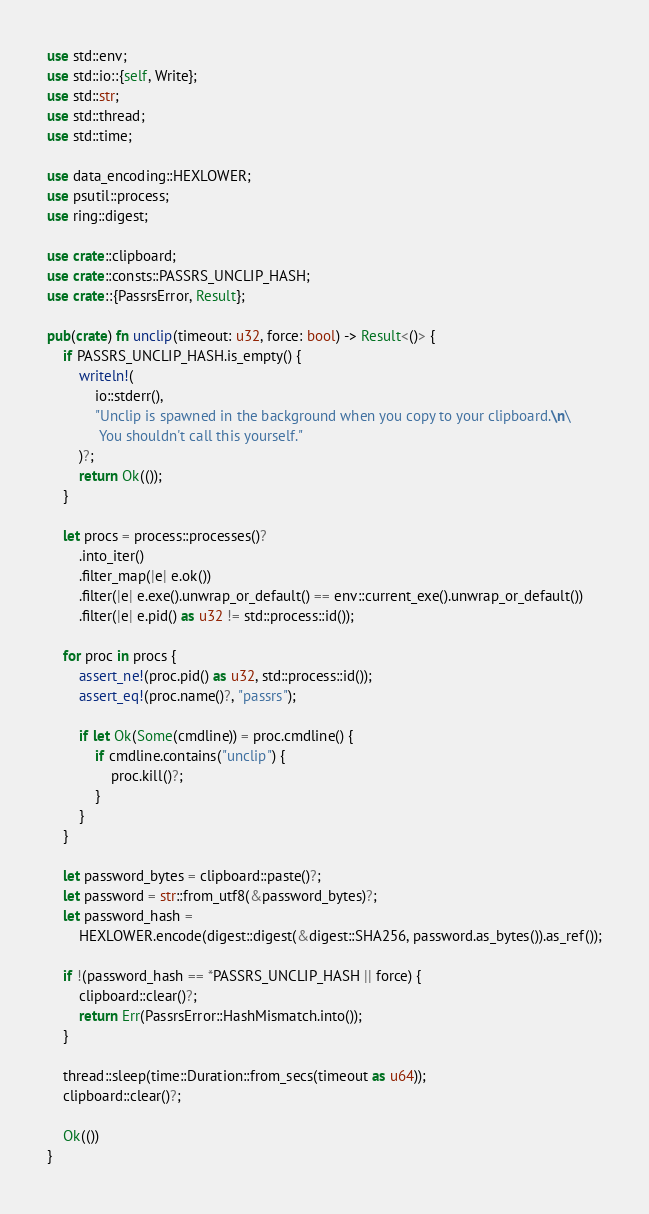Convert code to text. <code><loc_0><loc_0><loc_500><loc_500><_Rust_>use std::env;
use std::io::{self, Write};
use std::str;
use std::thread;
use std::time;

use data_encoding::HEXLOWER;
use psutil::process;
use ring::digest;

use crate::clipboard;
use crate::consts::PASSRS_UNCLIP_HASH;
use crate::{PassrsError, Result};

pub(crate) fn unclip(timeout: u32, force: bool) -> Result<()> {
    if PASSRS_UNCLIP_HASH.is_empty() {
        writeln!(
            io::stderr(),
            "Unclip is spawned in the background when you copy to your clipboard.\n\
             You shouldn't call this yourself."
        )?;
        return Ok(());
    }

    let procs = process::processes()?
        .into_iter()
        .filter_map(|e| e.ok())
        .filter(|e| e.exe().unwrap_or_default() == env::current_exe().unwrap_or_default())
        .filter(|e| e.pid() as u32 != std::process::id());

    for proc in procs {
        assert_ne!(proc.pid() as u32, std::process::id());
        assert_eq!(proc.name()?, "passrs");

        if let Ok(Some(cmdline)) = proc.cmdline() {
            if cmdline.contains("unclip") {
                proc.kill()?;
            }
        }
    }

    let password_bytes = clipboard::paste()?;
    let password = str::from_utf8(&password_bytes)?;
    let password_hash =
        HEXLOWER.encode(digest::digest(&digest::SHA256, password.as_bytes()).as_ref());

    if !(password_hash == *PASSRS_UNCLIP_HASH || force) {
        clipboard::clear()?;
        return Err(PassrsError::HashMismatch.into());
    }

    thread::sleep(time::Duration::from_secs(timeout as u64));
    clipboard::clear()?;

    Ok(())
}
</code> 